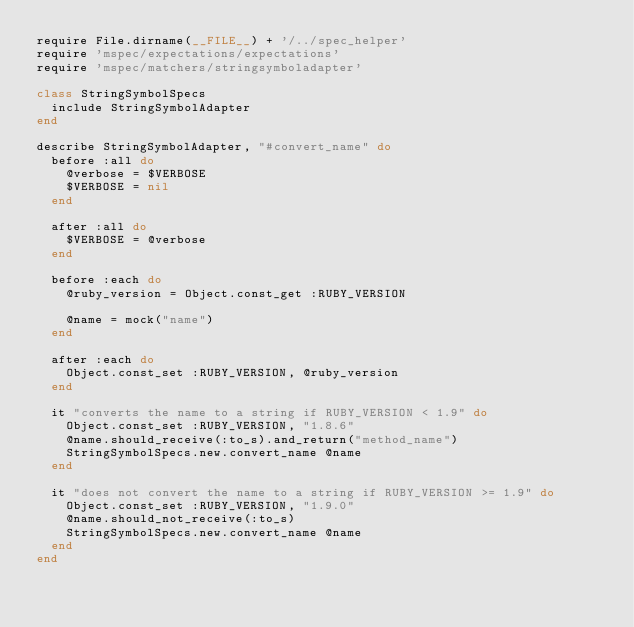Convert code to text. <code><loc_0><loc_0><loc_500><loc_500><_Ruby_>require File.dirname(__FILE__) + '/../spec_helper'
require 'mspec/expectations/expectations'
require 'mspec/matchers/stringsymboladapter'

class StringSymbolSpecs
  include StringSymbolAdapter
end

describe StringSymbolAdapter, "#convert_name" do
  before :all do
    @verbose = $VERBOSE
    $VERBOSE = nil
  end

  after :all do
    $VERBOSE = @verbose
  end

  before :each do
    @ruby_version = Object.const_get :RUBY_VERSION

    @name = mock("name")
  end

  after :each do
    Object.const_set :RUBY_VERSION, @ruby_version
  end

  it "converts the name to a string if RUBY_VERSION < 1.9" do
    Object.const_set :RUBY_VERSION, "1.8.6"
    @name.should_receive(:to_s).and_return("method_name")
    StringSymbolSpecs.new.convert_name @name
  end

  it "does not convert the name to a string if RUBY_VERSION >= 1.9" do
    Object.const_set :RUBY_VERSION, "1.9.0"
    @name.should_not_receive(:to_s)
    StringSymbolSpecs.new.convert_name @name
  end
end
</code> 